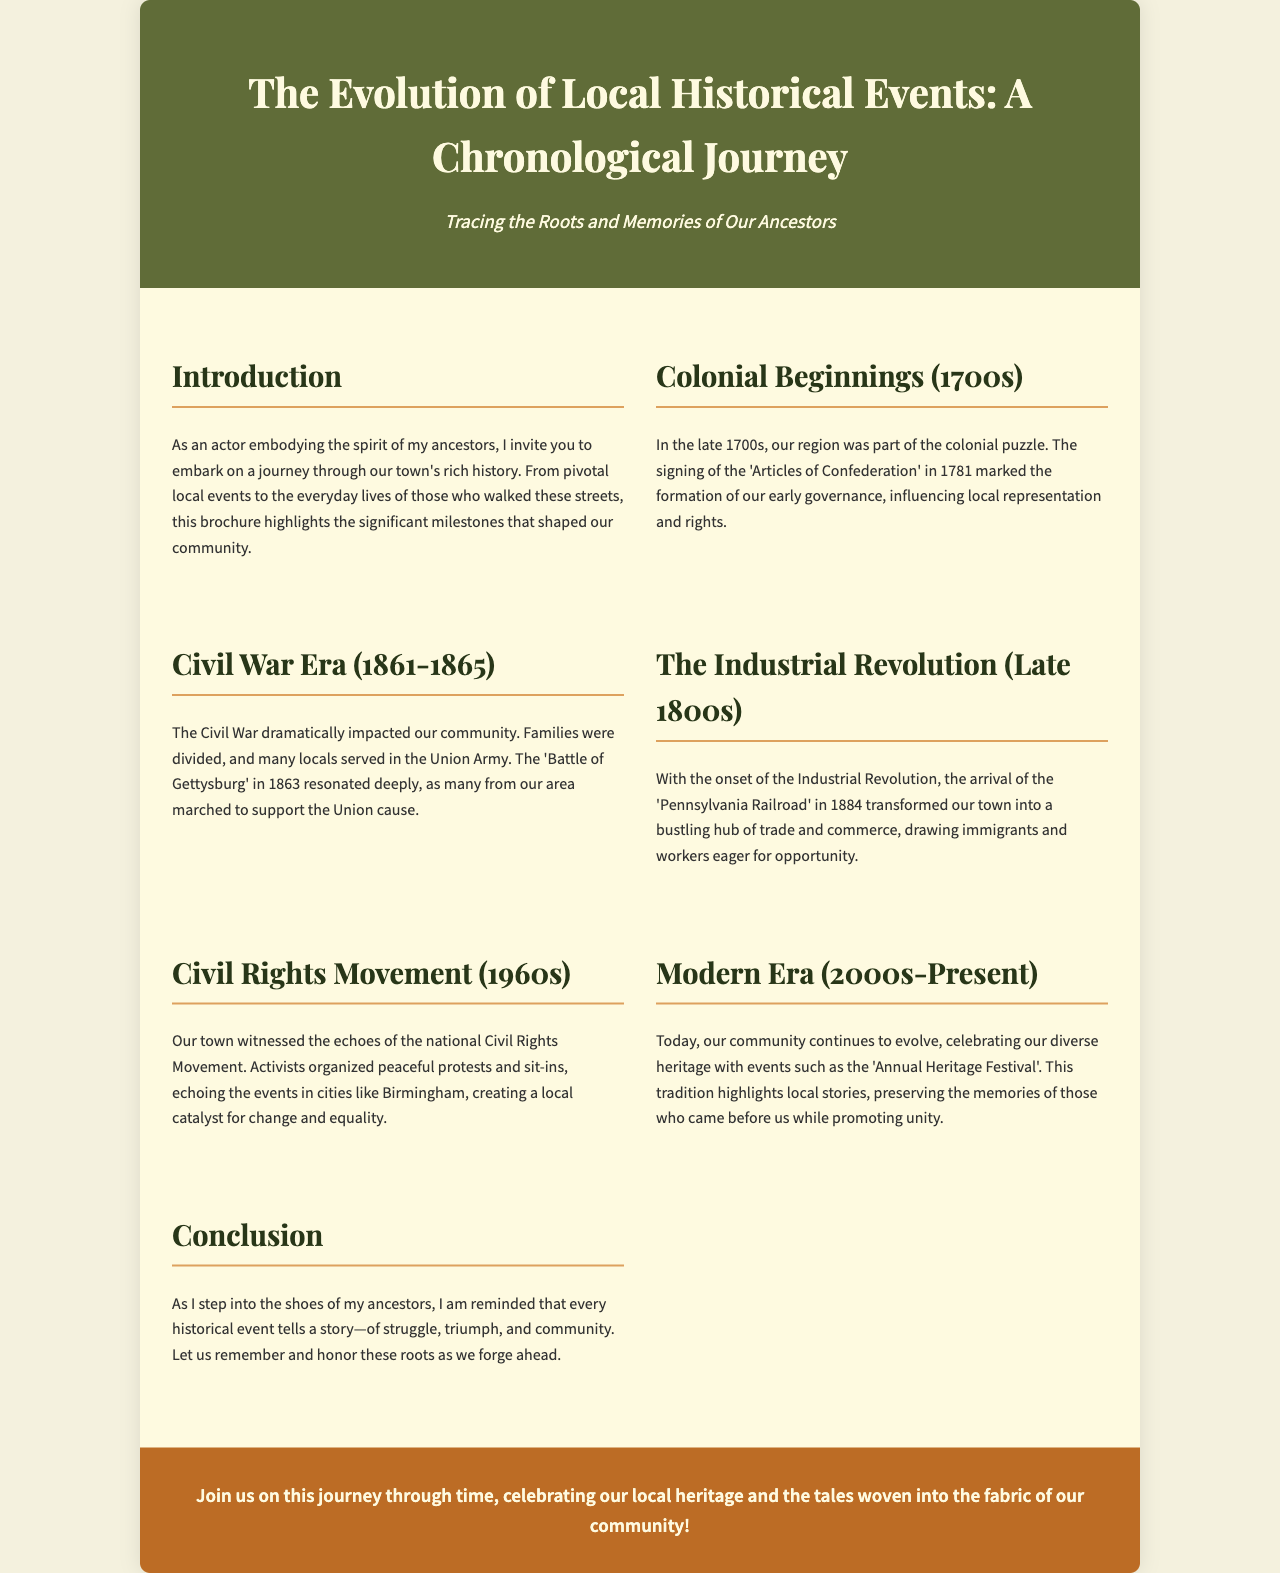what is the title of the brochure? The title of the brochure is presented at the top and is "The Evolution of Local Historical Events: A Chronological Journey."
Answer: The Evolution of Local Historical Events: A Chronological Journey what century does the Civil War Era fall into? The document specifies the dates for the Civil War Era as between 1861 and 1865, which is in the 19th century.
Answer: 19th century which event marked the beginning of local governance in the 1700s? The document mentions the signing of the 'Articles of Confederation' in 1781, which marked the formation of early governance.
Answer: Articles of Confederation what significant infrastructure arrived in 1884? The 'Pennsylvania Railroad' is noted in the document as a transformative infrastructure that arrived in 1884.
Answer: Pennsylvania Railroad which movement echoed in our town during the 1960s? The document highlights the 'Civil Rights Movement' as a significant national event that resonated locally during this time.
Answer: Civil Rights Movement what type of local event does the community celebrate today? The brochure mentions the 'Annual Heritage Festival' as a modern event that celebrates local heritage.
Answer: Annual Heritage Festival what is the main theme of the document? The document's theme revolves around the journey through local history and the significance of ancestors' stories.
Answer: Local history and ancestors' stories how does the brochure conclude? The conclusion emphasizes the importance of remembering and honoring historical events that shape the community as we move forward.
Answer: Remembering and honoring historical events 